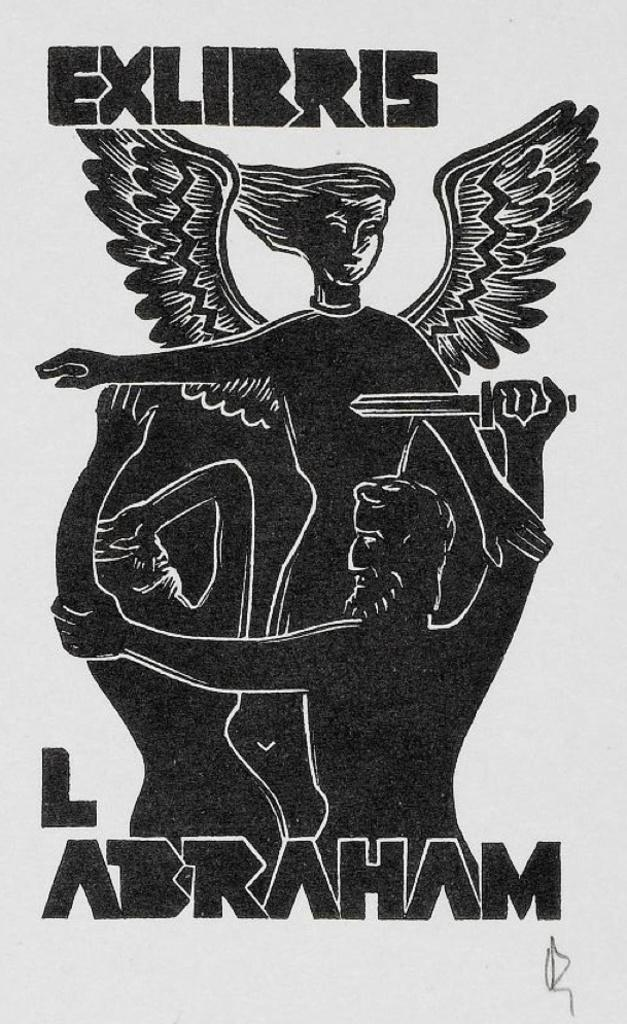What type of visual might the image be? The image might be a poster. Where is the text located on the poster? The text is at the top and bottom of the poster. What is depicted in the center of the poster? There is an image of three people in the center of the poster. What color is the background of the poster? The background of the poster is white. How many boats are visible in the image? There are no boats present in the image. Are there any bikes shown in the image? There are no bikes present in the image. 